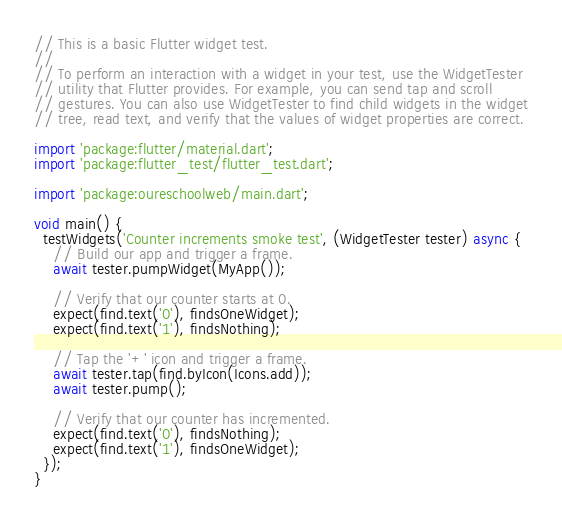<code> <loc_0><loc_0><loc_500><loc_500><_Dart_>// This is a basic Flutter widget test.
//
// To perform an interaction with a widget in your test, use the WidgetTester
// utility that Flutter provides. For example, you can send tap and scroll
// gestures. You can also use WidgetTester to find child widgets in the widget
// tree, read text, and verify that the values of widget properties are correct.

import 'package:flutter/material.dart';
import 'package:flutter_test/flutter_test.dart';

import 'package:oureschoolweb/main.dart';

void main() {
  testWidgets('Counter increments smoke test', (WidgetTester tester) async {
    // Build our app and trigger a frame.
    await tester.pumpWidget(MyApp());

    // Verify that our counter starts at 0.
    expect(find.text('0'), findsOneWidget);
    expect(find.text('1'), findsNothing);

    // Tap the '+' icon and trigger a frame.
    await tester.tap(find.byIcon(Icons.add));
    await tester.pump();

    // Verify that our counter has incremented.
    expect(find.text('0'), findsNothing);
    expect(find.text('1'), findsOneWidget);
  });
}
</code> 